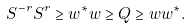<formula> <loc_0><loc_0><loc_500><loc_500>S ^ { - r } S ^ { r } \geq w ^ { * } w \geq Q \geq w w ^ { * } .</formula> 